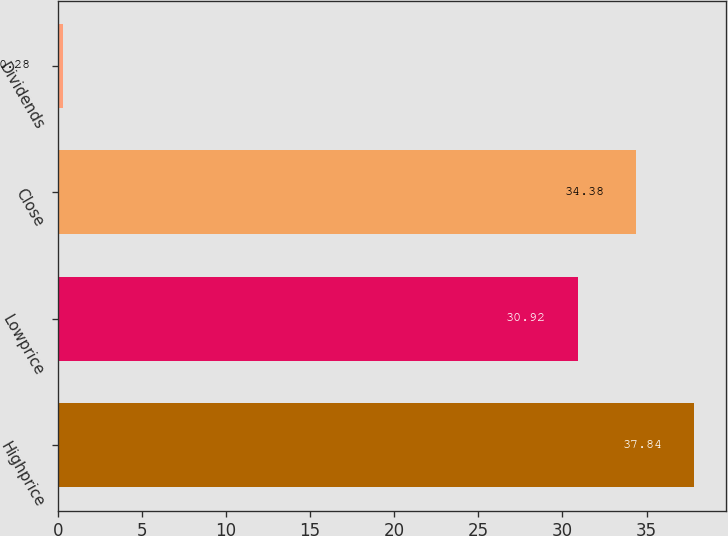Convert chart to OTSL. <chart><loc_0><loc_0><loc_500><loc_500><bar_chart><fcel>Highprice<fcel>Lowprice<fcel>Close<fcel>Dividends<nl><fcel>37.84<fcel>30.92<fcel>34.38<fcel>0.28<nl></chart> 